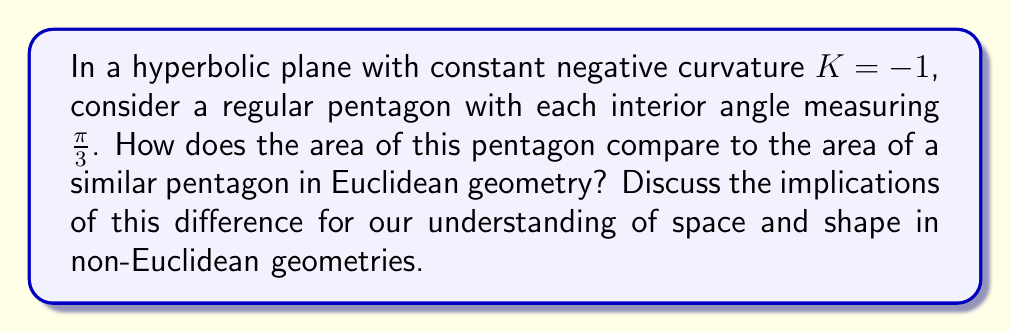Show me your answer to this math problem. Let's approach this step-by-step:

1) In hyperbolic geometry, the area of a polygon is given by the Gauss-Bonnet formula:

   $$A = (n-2)\pi - \sum_{i=1}^n \theta_i$$

   where $n$ is the number of sides, and $\theta_i$ are the interior angles.

2) For our regular pentagon, $n = 5$ and each $\theta_i = \frac{\pi}{3}$. Substituting:

   $$A = (5-2)\pi - 5 \cdot \frac{\pi}{3} = 3\pi - \frac{5\pi}{3} = \frac{4\pi}{3}$$

3) In Euclidean geometry, the sum of interior angles of a pentagon is always $(5-2)\pi = 3\pi$. For a regular Euclidean pentagon, each angle would be $\frac{3\pi}{5}$.

4) The area of a regular Euclidean pentagon with side length $a$ is:

   $$A_E = \frac{1}{4}\sqrt{25+10\sqrt{5}}a^2$$

5) We can't directly compare these areas because the hyperbolic area doesn't depend on side length. However, we can observe that:
   - The hyperbolic pentagon area is constant, regardless of size.
   - The Euclidean pentagon area grows quadratically with side length.

6) This implies that for very small pentagons, the hyperbolic area will be larger than the Euclidean area. For very large pentagons, the Euclidean area will be larger.

7) The constant area in hyperbolic space suggests that as shapes grow larger, they become more "efficient" in terms of enclosing area relative to their perimeter.

This difference highlights how our intuitive understanding of space and shape, based on Euclidean geometry, can be challenged in non-Euclidean spaces. It invites readers to consider how the nature of space itself might affect geometric properties we often take for granted.
Answer: The hyperbolic pentagon has constant area $\frac{4\pi}{3}$, independent of size, while the Euclidean pentagon's area grows quadratically with side length, leading to fundamentally different spatial relationships. 